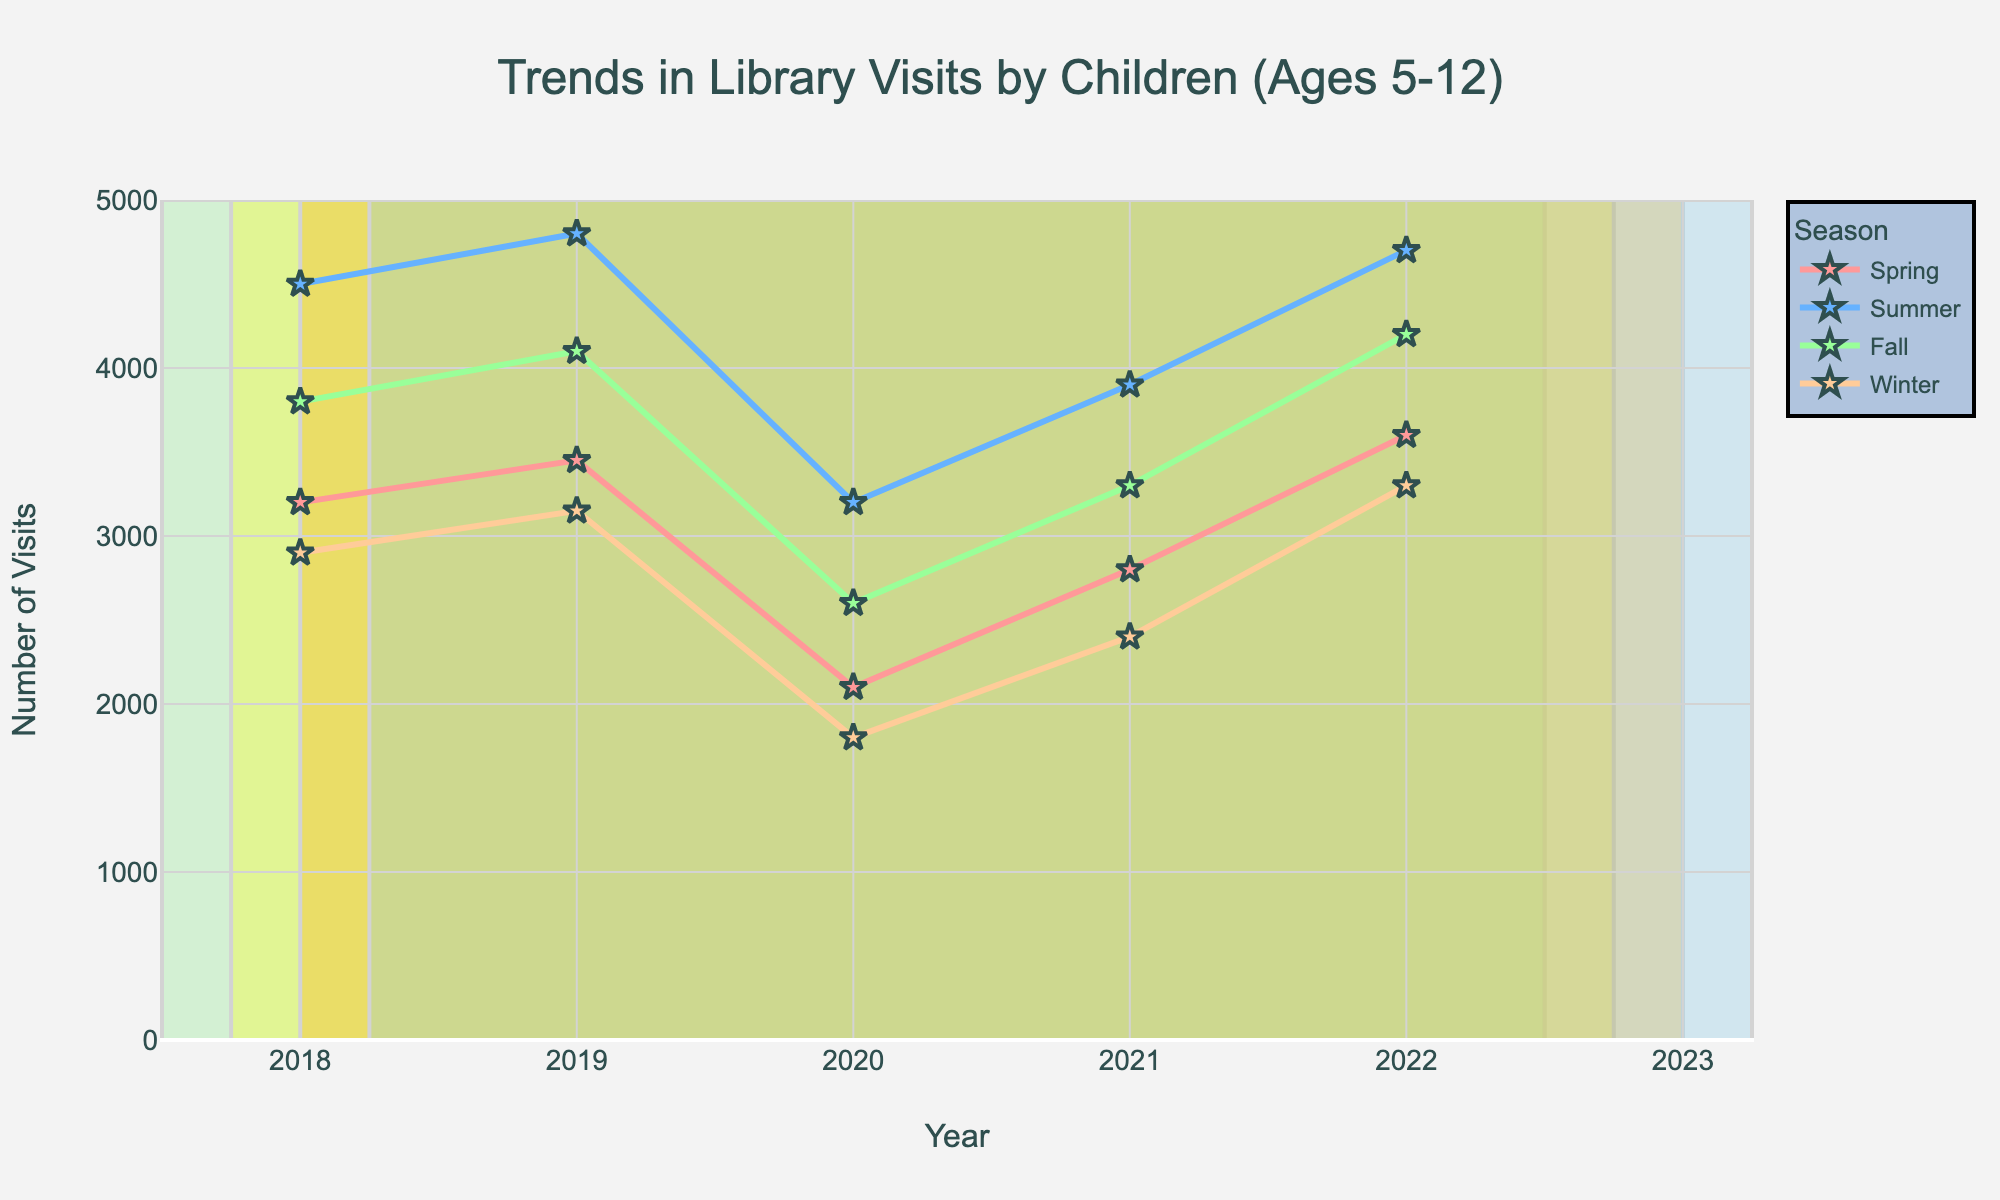What season had the highest number of visits in 2022? In 2022, look at the highest point among the four seasons. It is in the summer.
Answer: Summer How many more visits were there in Summer 2022 compared to Winter 2022? In 2022, summer had 4,700 visits while winter had 3,300 visits. The difference is 4,700 - 3,300.
Answer: 1,400 Which season showed the largest increase in visits from 2021 to 2022? Compare the increase in visits from 2021 to 2022 across all seasons (Spring: 800, Summer: 800, Fall: 900, Winter: 1,100). Winter showed the largest increase.
Answer: Winter What is the average number of visits in Spring over the 5 years? Sum the visits in Spring over the 5 years (3,200 + 3,450 + 2,100 + 2,800 + 3,600 = 15,150) and divide by 5.
Answer: 3,030 Which season had the lowest number of visits in 2020? Look at the lowest point among the four seasons in 2020. It is in the winter.
Answer: Winter Over the 5 years, which season showed the most consistent (least variable) number of visits? Compare the range (difference between maximum and minimum visits) for each season: Spring (1,500), Summer (1,600), Fall (1,500), Winter (1,350). Winter has the smallest range, indicating it is the most consistent.
Answer: Winter What is the total number of visits in Fall over the 5 years? Sum the visits in Fall over the 5 years (3,800 + 4,100 + 2,600 + 3,300 + 4,200).
Answer: 18,000 Which year showed the greatest overall decrease in visits across all seasons? Compare the decrease in visits from the previous year for all years: from 2019 to 2020 (Spring: -1,350, Summer: -1,600, Fall: -1,500, Winter: -1,350) shows the greatest overall decrease.
Answer: 2020 